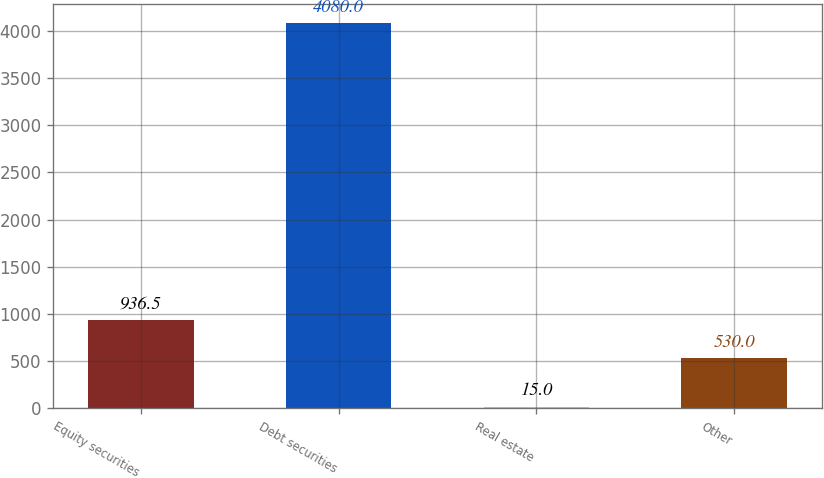<chart> <loc_0><loc_0><loc_500><loc_500><bar_chart><fcel>Equity securities<fcel>Debt securities<fcel>Real estate<fcel>Other<nl><fcel>936.5<fcel>4080<fcel>15<fcel>530<nl></chart> 